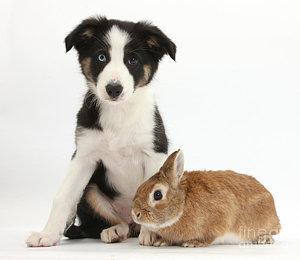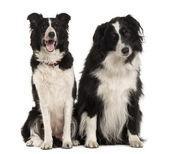The first image is the image on the left, the second image is the image on the right. Considering the images on both sides, is "There is exactly two dogs in the right image." valid? Answer yes or no. Yes. The first image is the image on the left, the second image is the image on the right. Given the left and right images, does the statement "The combined images contain three dogs, and in one image, a black-and-white dog sits upright and all alone." hold true? Answer yes or no. No. 